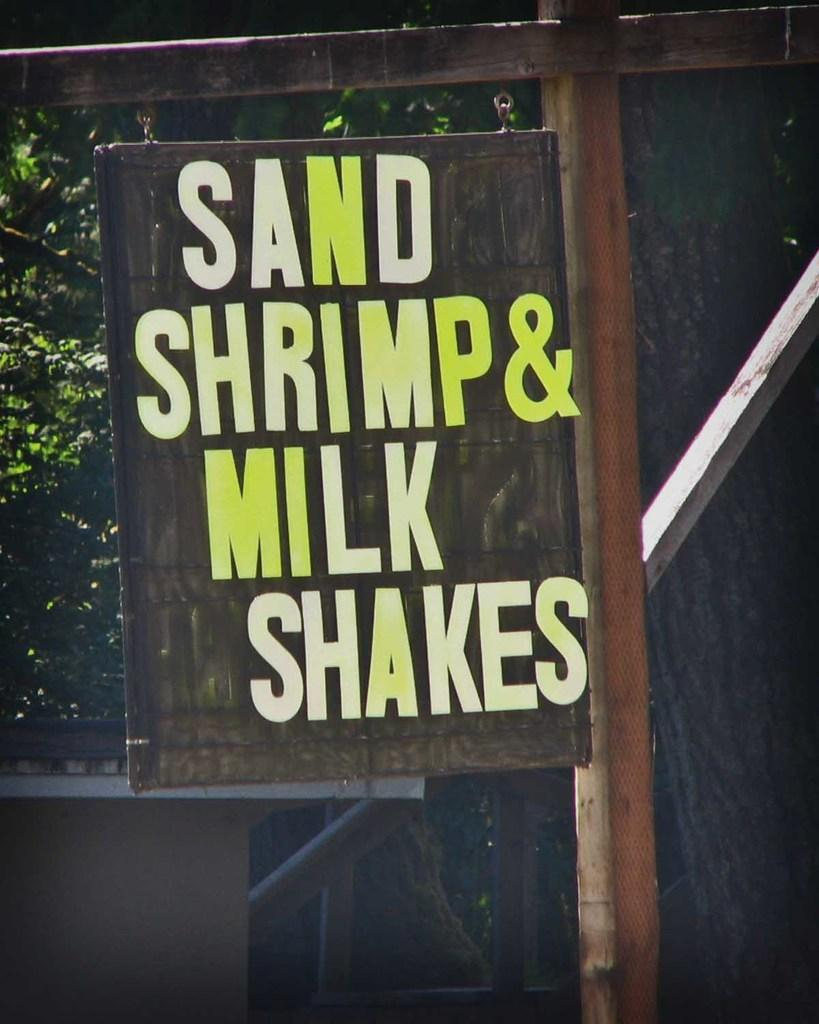What is written or displayed on the board in the image? There is text on a board in the image. Can you describe any other elements in the image besides the board? The trunk of a tree is visible on the right side of the image. What color is the grape that is being kicked in the image? There is no grape or kicking activity present in the image. 